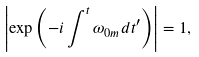Convert formula to latex. <formula><loc_0><loc_0><loc_500><loc_500>\left | \exp \left ( - i \int ^ { t } \omega _ { 0 m } d t ^ { \prime } \right ) \right | = 1 ,</formula> 